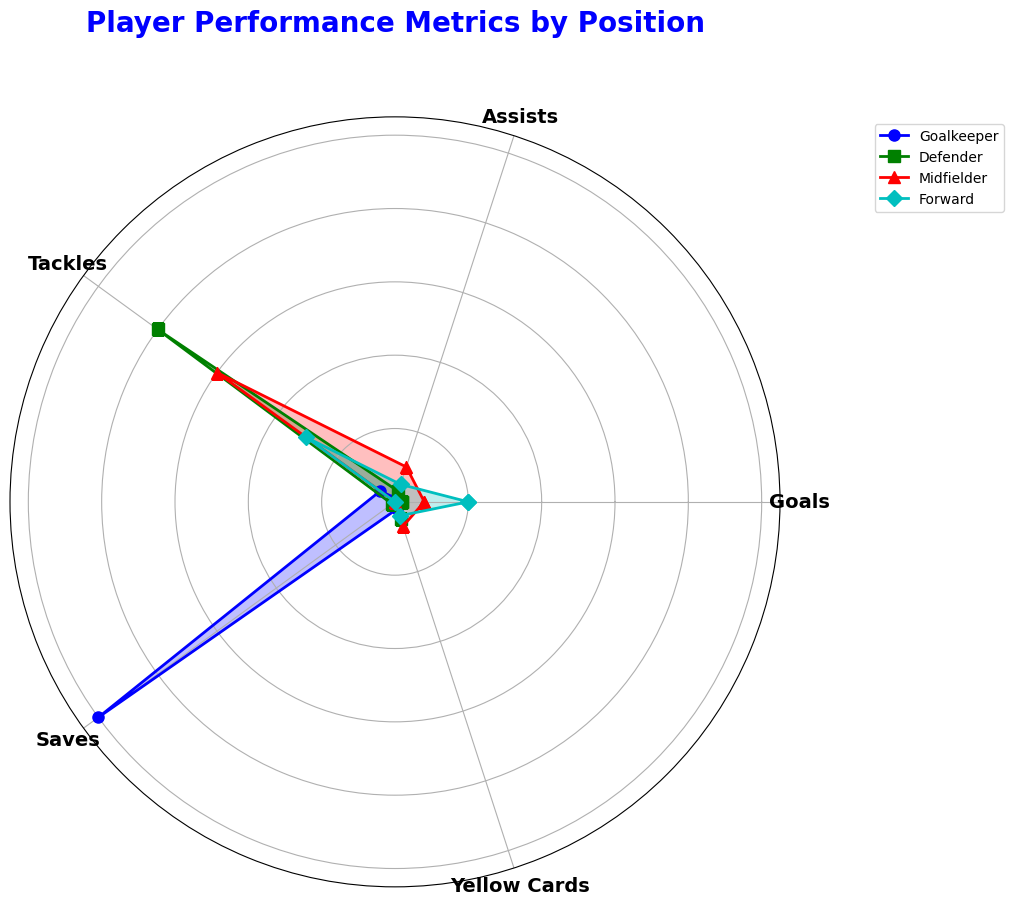Which position has the highest number of goals? By examining the radar chart, look for the metric 'Goals' and identify the position with the longest length or highest value in that specific segment.
Answer: Forward How many saves does the Goalkeeper have compared to the Defender? Locate the 'Saves' metric on the radar chart. Find the respective values for both the Goalkeeper and the Defender, and calculate the difference: 100 (Goalkeeper) - 1 (Defender).
Answer: 99 Rank the positions by the number of Yellow Cards from lowest to highest. Observe the 'Yellow Cards' metric on the radar chart. Note down the values for each position and then arrange them: Goalkeeper (2), Forward (4), Defender (5), Midfielder (7).
Answer: Goalkeeper, Forward, Defender, Midfielder Are the number of Tackles higher for Defenders or Midfielders? Check the 'Tackles' metric on the radar chart and compare the lengths or values for both Defenders and Midfielders. Defenders have 80 while Midfielders have 60.
Answer: Defenders What is the average number of Assists across all positions? Sum the 'Assists' values for all positions: 1 (Goalkeeper) + 3 (Defender) + 10 (Midfielder) + 5 (Forward). Then divide by the number of positions (4): (1 + 3 + 10 + 5) / 4.
Answer: 4.75 Which position has the least contribution in terms of Goals and what is that value? Look for the position with the shortest length or lowest value in the 'Goals' segment on the radar chart. The Goalkeeper has a value of 0.
Answer: Goalkeeper How much higher is the Midfielder's Assists compared to the Forward? Find the 'Assists' values for both Midfielder and Forward, then subtract the Forward's from the Midfielder's: 10 (Midfielder) - 5 (Forward).
Answer: 5 What is the total number of Yellow Cards given to Defenders and Forwards combined? Add the 'Yellow Cards' metrics for Defenders and Forwards: 5 (Defender) + 4 (Forward).
Answer: 9 For which metric does the Goalkeeper excel the most compared to other positions? Look at the sharpest point or longest segment in the Goalkeeper's radar chart representation. The 'Saves' metric is the highest compared to other positions.
Answer: Saves 